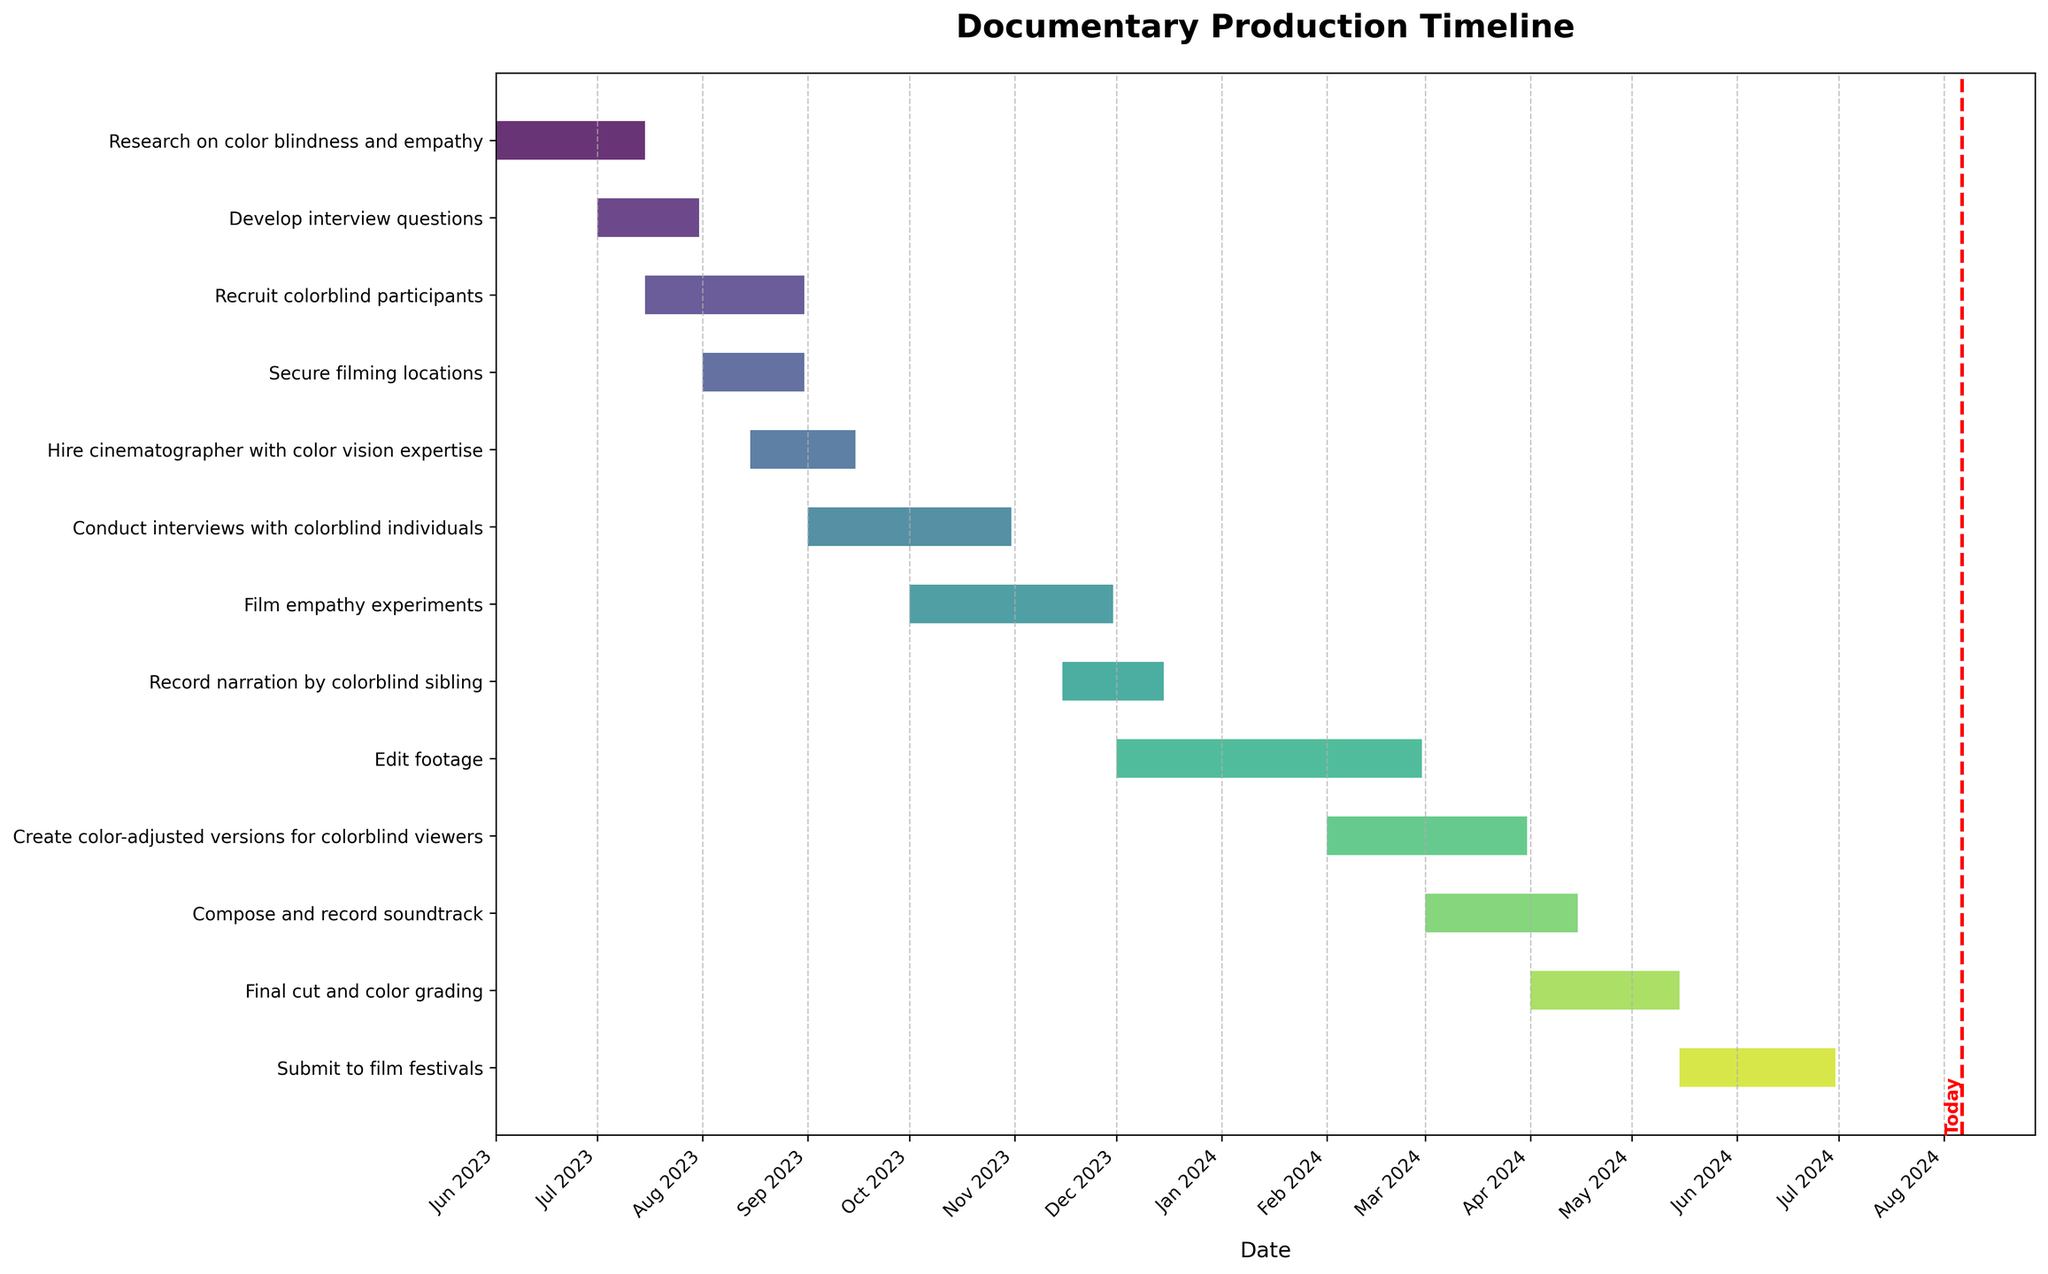When does the "Research on color blindness and empathy" task start and end? The "Research on color blindness and empathy" task starts at the point corresponding to the beginning of the Gantt chart on June 1, 2023, and ends at the point corresponding to July 15, 2023.
Answer: June 1, 2023 to July 15, 2023 Which task has the longest duration? By observing the length of the bars in the Gantt chart, we can see that the task "Edit footage" has the longest bar, indicating it spans the most months.
Answer: Edit footage How many tasks start in August 2023? We can count the bars that start within August 2023. There are three tasks: "Secure filming locations," "Recruit colorblind participants," and "Hire cinematographer with color vision expertise."
Answer: 3 Which stage of the documentary production has the most overlap with other tasks? By visually inspecting the Gantt chart, the pre-production stage (including "Research," "Develop interview questions," "Recruit participants," and "Secure filming locations") has the most overlapping task bars.
Answer: Pre-production Calculate the total duration (in days) of "Film empathy experiments" and "Record narration by colorblind sibling." The "Film empathy experiments" task lasts from October 1, 2023, to November 30, 2023 (61 days). The "Record narration by colorblind sibling" task lasts from November 15, 2023, to December 15, 2023 (30 days). Summing these up gives a total duration of 61 + 30.
Answer: 91 days How many tasks are still ongoing as of today? By identifying the vertical red line labeled "Today" and noting which bars overlap with this line, we can count the ongoing tasks. Let's assume today is in the middle of the "Conduct interviews" and beginning of "Film empathy experiments."
Answer: 2 What is the total duration of the "Edit footage" task? The "Edit footage" task runs from December 1, 2023, to February 29, 2024. The duration is calculated based on these dates.
Answer: 90 days (assuming 2024 is a leap year) Identify which task ends last in the production timeline. The task that finishes at the furthest point to the right on the Gantt chart is "Submit to film festivals," which ends on June 30, 2024.
Answer: Submit to film festivals Which two tasks have significant overlap, starting and ending around the same period? Observing the chart, we can see that "Film empathy experiments" (October 1, 2023 to November 30, 2023) and "Conduct interviews with colorblind individuals" (September 1, 2023 to October 31, 2023) have significant overlapping periods.
Answer: Film empathy experiments and Conduct interviews with colorblind individuals 